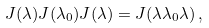<formula> <loc_0><loc_0><loc_500><loc_500>J ( \lambda ) J ( \lambda _ { 0 } ) J ( \lambda ) = J ( \lambda \lambda _ { 0 } \lambda ) \, ,</formula> 